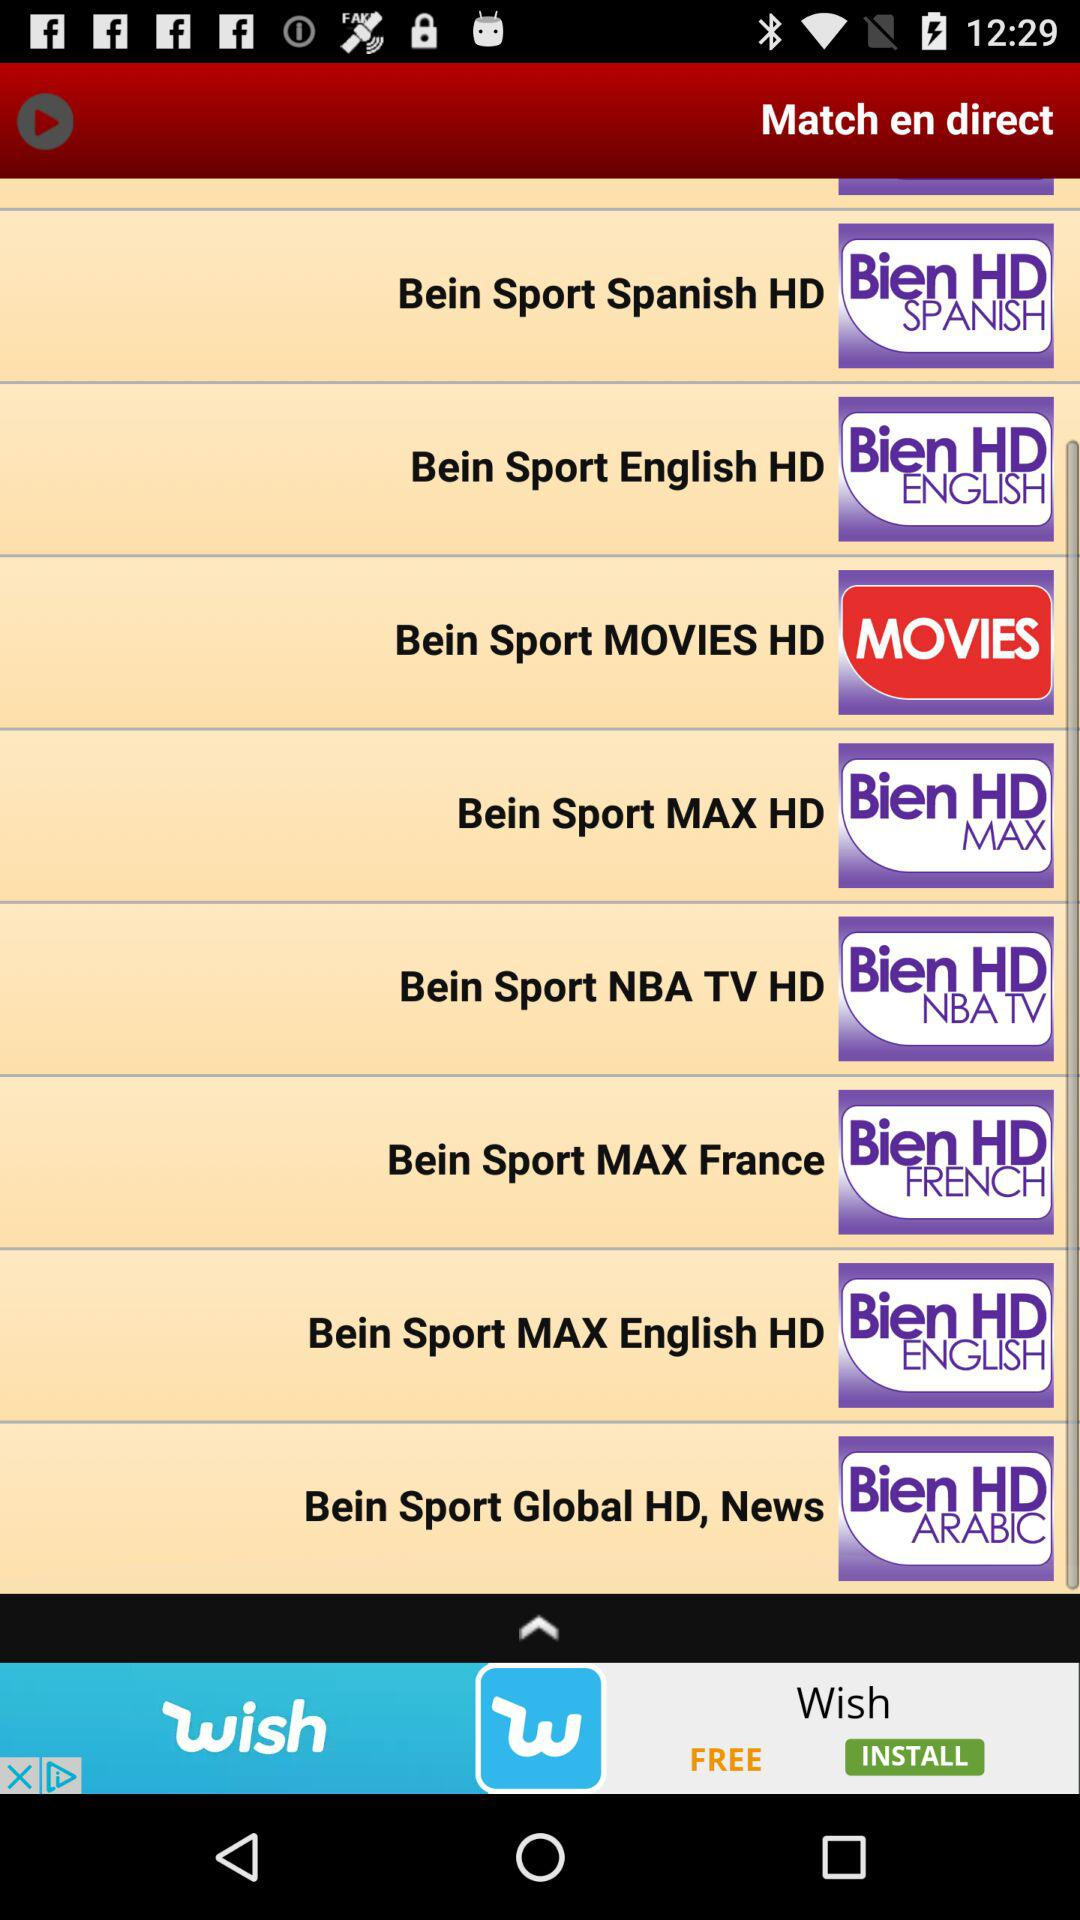Are there any channels in this list that broadcast in French? Indeed, there are channels for French-speaking audiences. As per the image, 'Bein Sport MAX France' and 'Bein Sport Global HD, News' have 'French' and 'Arabic' respectively in their titles, indicating language-specific content. 